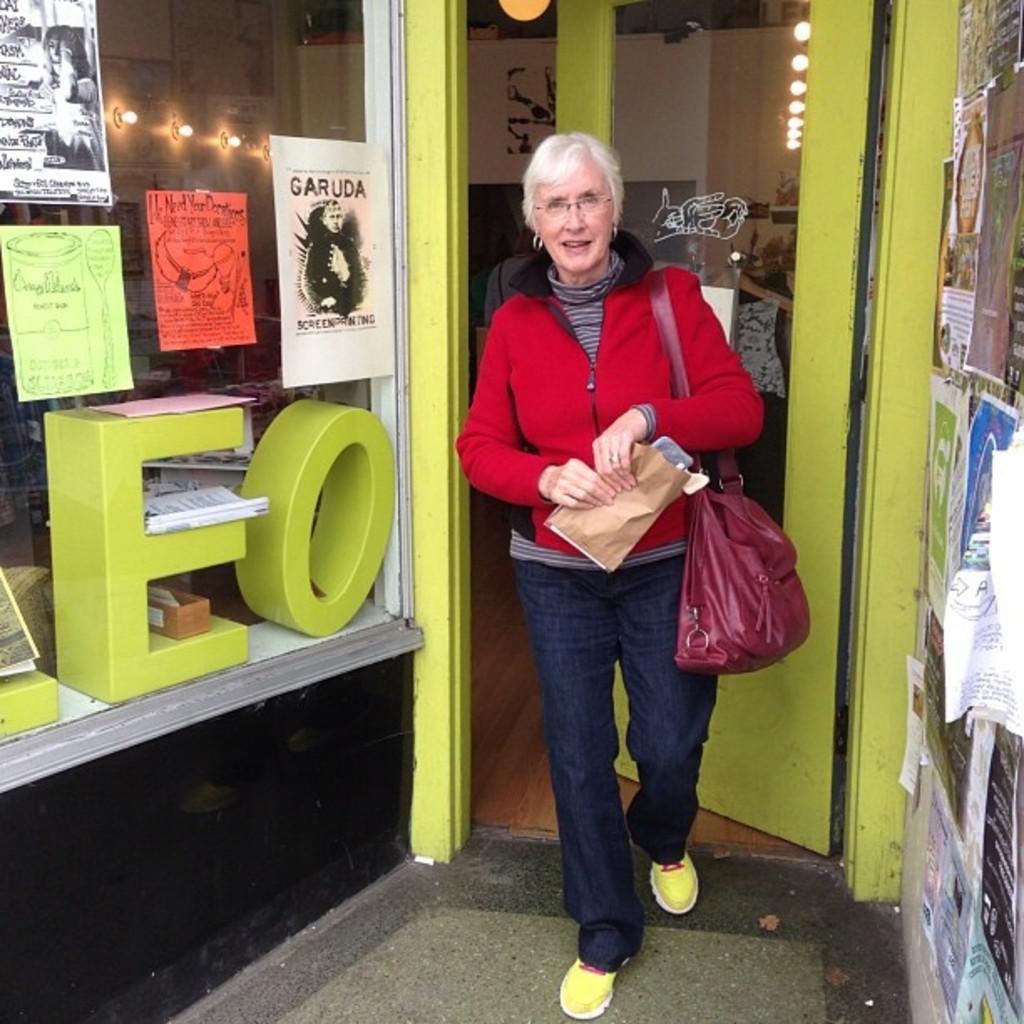In one or two sentences, can you explain what this image depicts? I think is picture is outside the store. There is a woman walking outside of the store. At the back there is a door and at the right there are posters on the wall and at the top there are lights. 